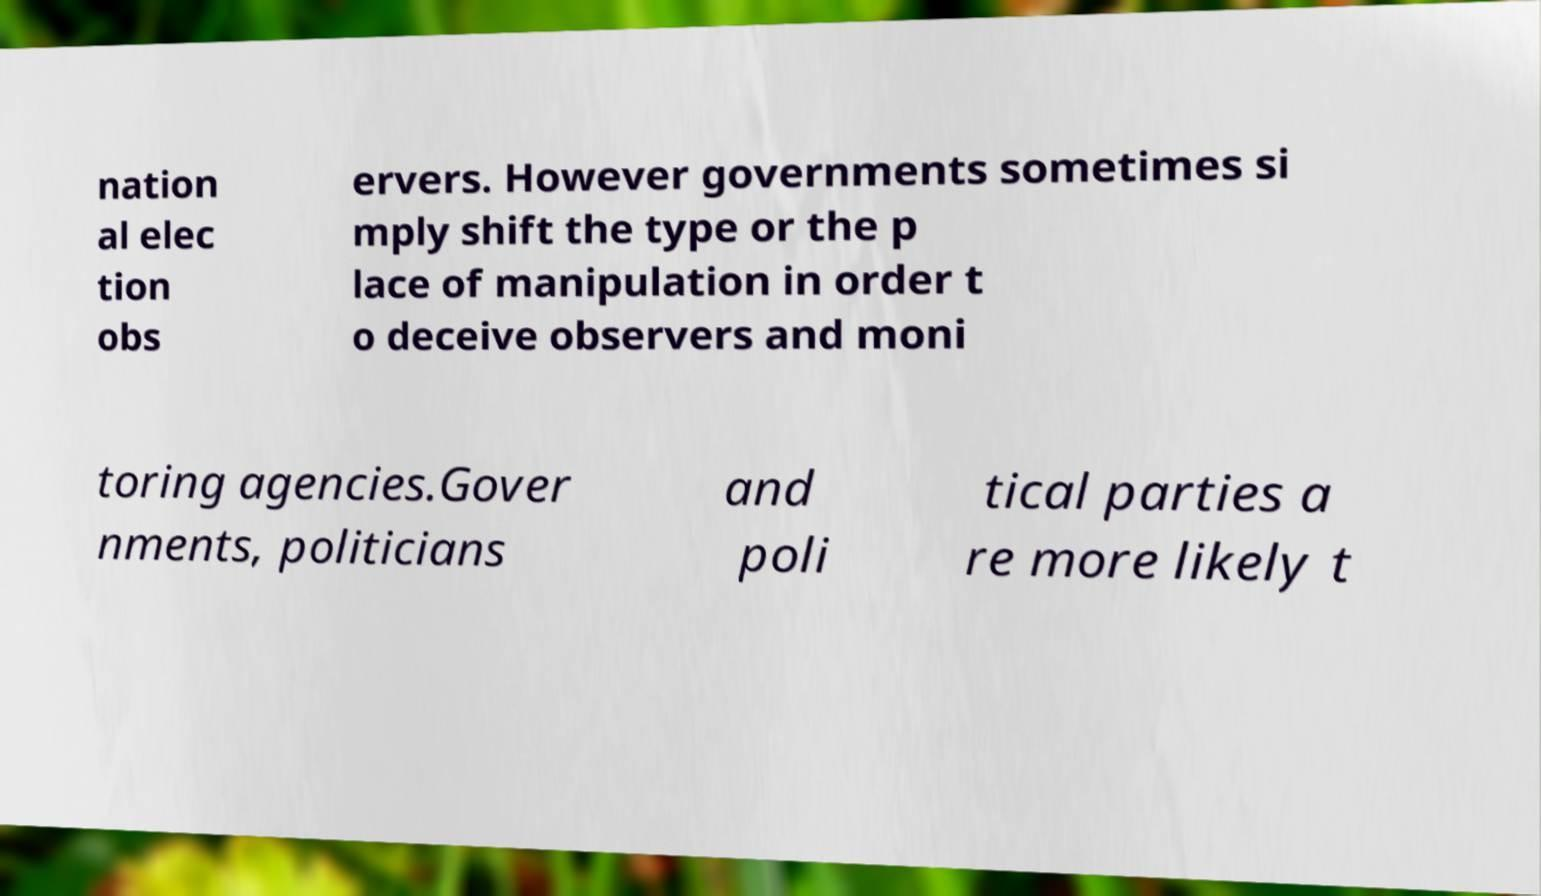Can you accurately transcribe the text from the provided image for me? nation al elec tion obs ervers. However governments sometimes si mply shift the type or the p lace of manipulation in order t o deceive observers and moni toring agencies.Gover nments, politicians and poli tical parties a re more likely t 